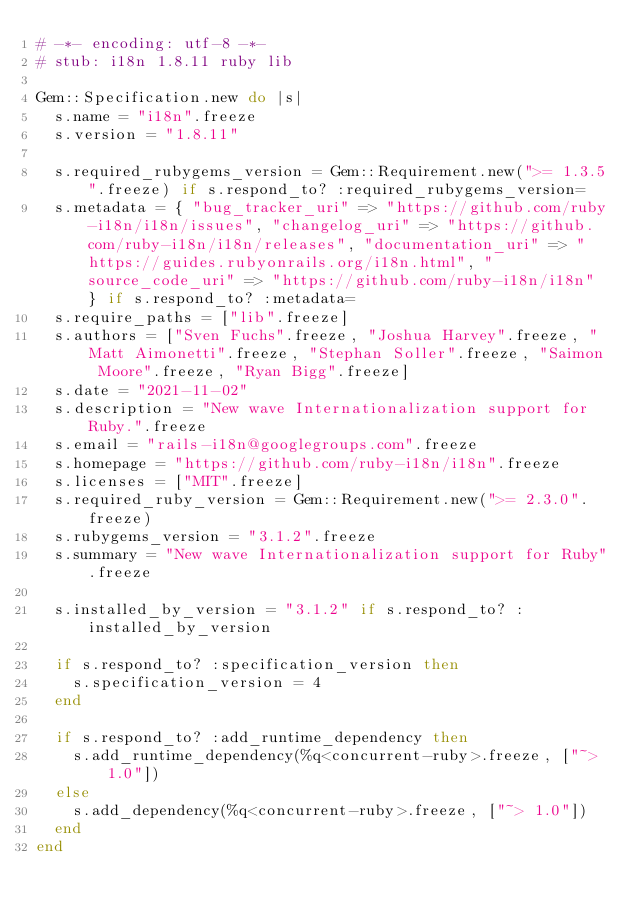<code> <loc_0><loc_0><loc_500><loc_500><_Ruby_># -*- encoding: utf-8 -*-
# stub: i18n 1.8.11 ruby lib

Gem::Specification.new do |s|
  s.name = "i18n".freeze
  s.version = "1.8.11"

  s.required_rubygems_version = Gem::Requirement.new(">= 1.3.5".freeze) if s.respond_to? :required_rubygems_version=
  s.metadata = { "bug_tracker_uri" => "https://github.com/ruby-i18n/i18n/issues", "changelog_uri" => "https://github.com/ruby-i18n/i18n/releases", "documentation_uri" => "https://guides.rubyonrails.org/i18n.html", "source_code_uri" => "https://github.com/ruby-i18n/i18n" } if s.respond_to? :metadata=
  s.require_paths = ["lib".freeze]
  s.authors = ["Sven Fuchs".freeze, "Joshua Harvey".freeze, "Matt Aimonetti".freeze, "Stephan Soller".freeze, "Saimon Moore".freeze, "Ryan Bigg".freeze]
  s.date = "2021-11-02"
  s.description = "New wave Internationalization support for Ruby.".freeze
  s.email = "rails-i18n@googlegroups.com".freeze
  s.homepage = "https://github.com/ruby-i18n/i18n".freeze
  s.licenses = ["MIT".freeze]
  s.required_ruby_version = Gem::Requirement.new(">= 2.3.0".freeze)
  s.rubygems_version = "3.1.2".freeze
  s.summary = "New wave Internationalization support for Ruby".freeze

  s.installed_by_version = "3.1.2" if s.respond_to? :installed_by_version

  if s.respond_to? :specification_version then
    s.specification_version = 4
  end

  if s.respond_to? :add_runtime_dependency then
    s.add_runtime_dependency(%q<concurrent-ruby>.freeze, ["~> 1.0"])
  else
    s.add_dependency(%q<concurrent-ruby>.freeze, ["~> 1.0"])
  end
end
</code> 